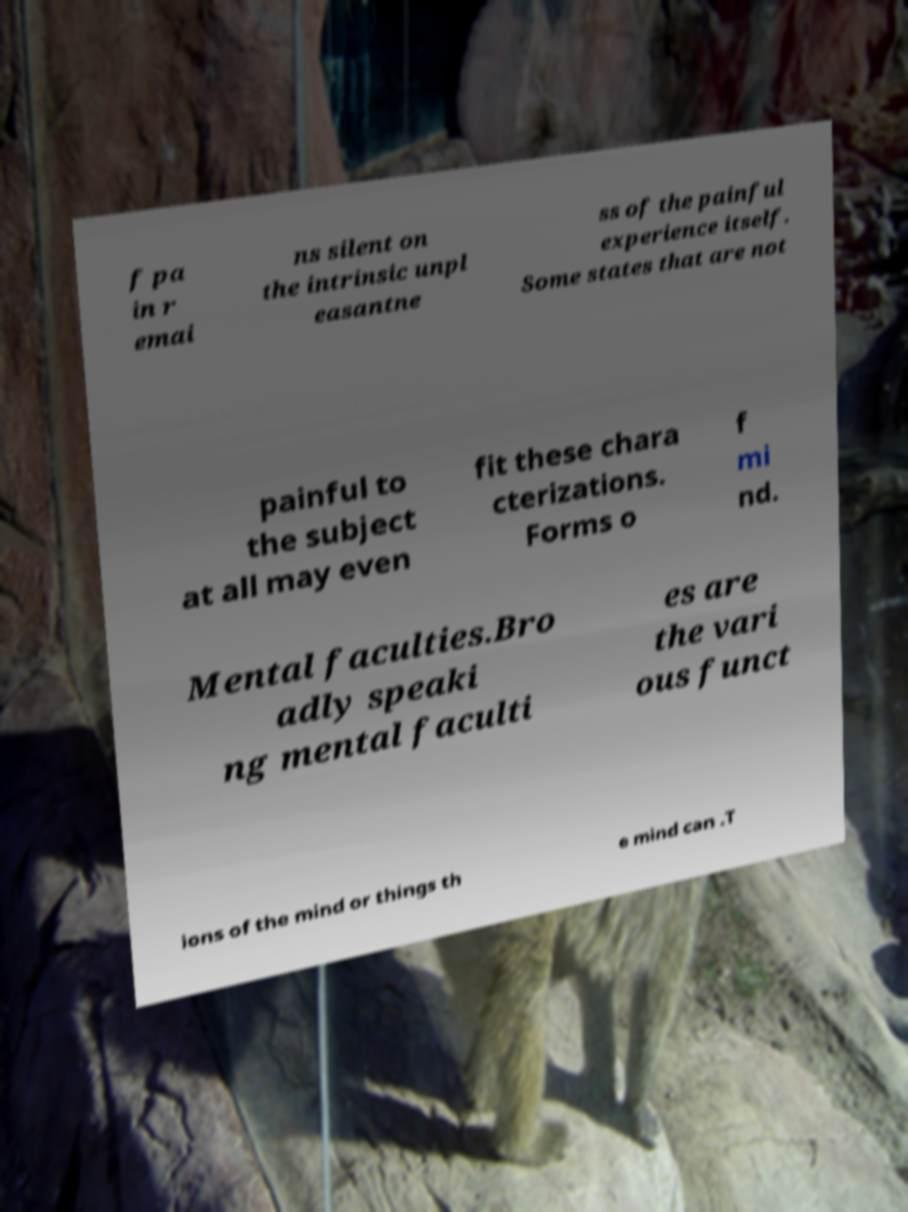I need the written content from this picture converted into text. Can you do that? f pa in r emai ns silent on the intrinsic unpl easantne ss of the painful experience itself. Some states that are not painful to the subject at all may even fit these chara cterizations. Forms o f mi nd. Mental faculties.Bro adly speaki ng mental faculti es are the vari ous funct ions of the mind or things th e mind can .T 